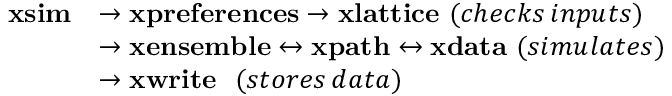Convert formula to latex. <formula><loc_0><loc_0><loc_500><loc_500>\begin{array} { r l } { x s i m } & { \rightarrow x p r e f e r e n c e s \rightarrow x l a t t i c e \, ( c h e c k s \, i n p u t s ) } \\ & { \rightarrow x e n s e m b l e \leftrightarrow x p a t h \leftrightarrow x d a t a \, ( s i m u l a t e s ) } \\ & { \rightarrow x w r i t e \, ( s t o r e s \, d a t a ) } \end{array}</formula> 